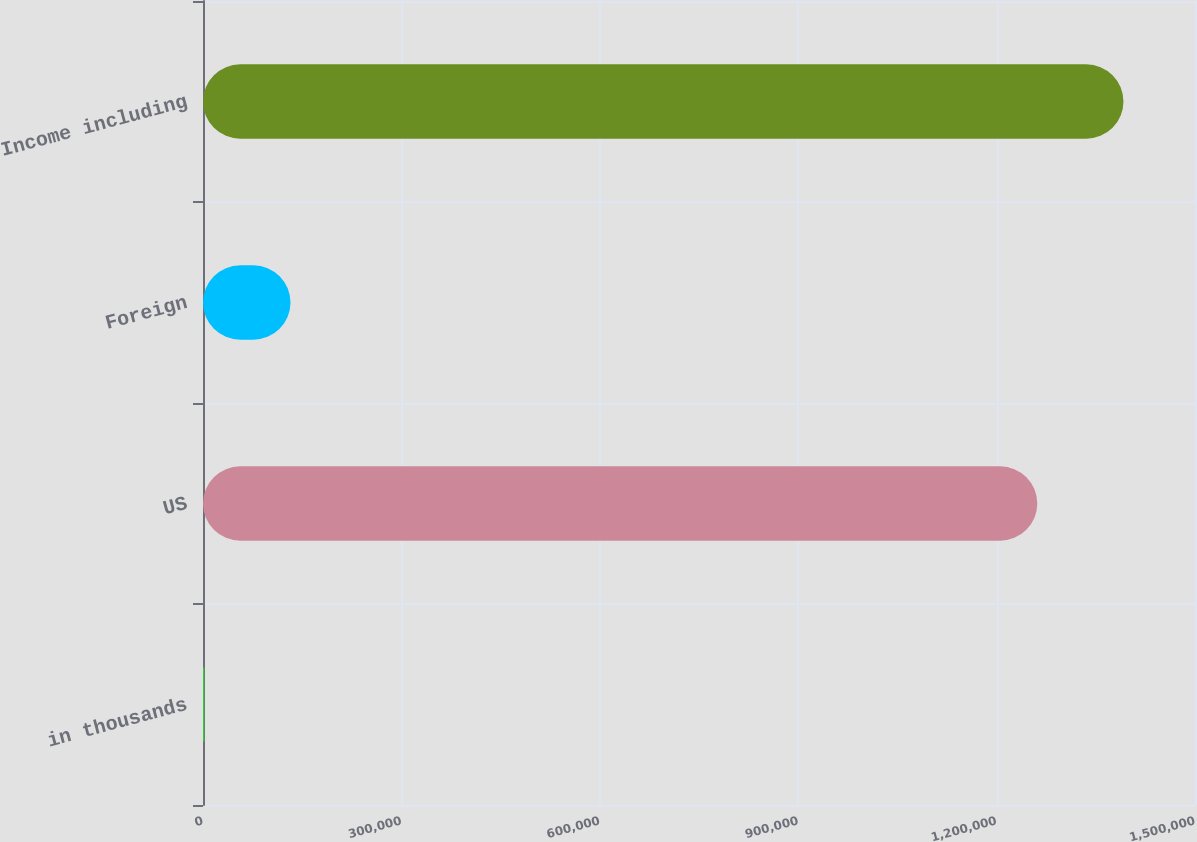Convert chart to OTSL. <chart><loc_0><loc_0><loc_500><loc_500><bar_chart><fcel>in thousands<fcel>US<fcel>Foreign<fcel>Income including<nl><fcel>2018<fcel>1.26154e+06<fcel>132304<fcel>1.39182e+06<nl></chart> 